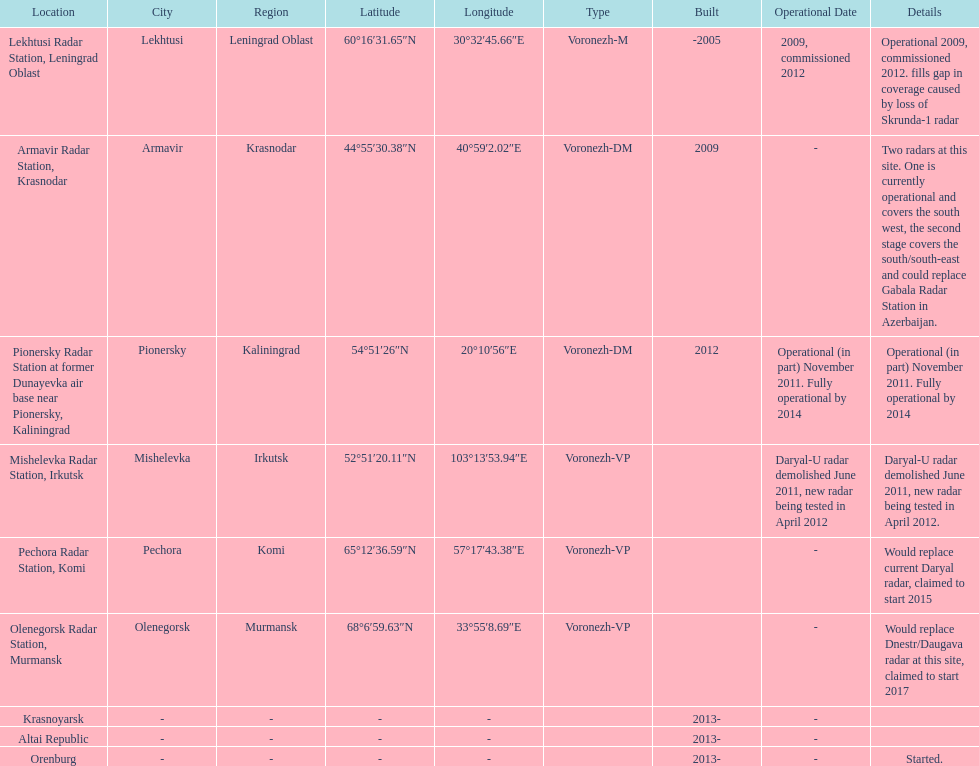Help me parse the entirety of this table. {'header': ['Location', 'City', 'Region', 'Latitude', 'Longitude', 'Type', 'Built', 'Operational Date', 'Details'], 'rows': [['Lekhtusi Radar Station, Leningrad Oblast', 'Lekhtusi', 'Leningrad Oblast', '60°16′31.65″N', '30°32′45.66″E', 'Voronezh-M', '-2005', '2009, commissioned 2012', 'Operational 2009, commissioned 2012. fills gap in coverage caused by loss of Skrunda-1 radar'], ['Armavir Radar Station, Krasnodar', 'Armavir', 'Krasnodar', '44°55′30.38″N', '40°59′2.02″E', 'Voronezh-DM', '2009', '-', 'Two radars at this site. One is currently operational and covers the south west, the second stage covers the south/south-east and could replace Gabala Radar Station in Azerbaijan.'], ['Pionersky Radar Station at former Dunayevka air base near Pionersky, Kaliningrad', 'Pionersky', 'Kaliningrad', '54°51′26″N', '20°10′56″E', 'Voronezh-DM', '2012', 'Operational (in part) November 2011. Fully operational by 2014', 'Operational (in part) November 2011. Fully operational by 2014'], ['Mishelevka Radar Station, Irkutsk', 'Mishelevka', 'Irkutsk', '52°51′20.11″N', '103°13′53.94″E', 'Voronezh-VP', '', 'Daryal-U radar demolished June 2011, new radar being tested in April 2012', 'Daryal-U radar demolished June 2011, new radar being tested in April 2012.'], ['Pechora Radar Station, Komi', 'Pechora', 'Komi', '65°12′36.59″N', '57°17′43.38″E', 'Voronezh-VP', '', '-', 'Would replace current Daryal radar, claimed to start 2015'], ['Olenegorsk Radar Station, Murmansk', 'Olenegorsk', 'Murmansk', '68°6′59.63″N', '33°55′8.69″E', 'Voronezh-VP', '', '-', 'Would replace Dnestr/Daugava radar at this site, claimed to start 2017'], ['Krasnoyarsk', '-', '-', '-', '-', '', '2013-', '-', ''], ['Altai Republic', '-', '-', '-', '-', '', '2013-', '-', ''], ['Orenburg', '-', '-', '-', '-', '', '2013-', '-', 'Started.']]} Which site has the most radars? Armavir Radar Station, Krasnodar. 